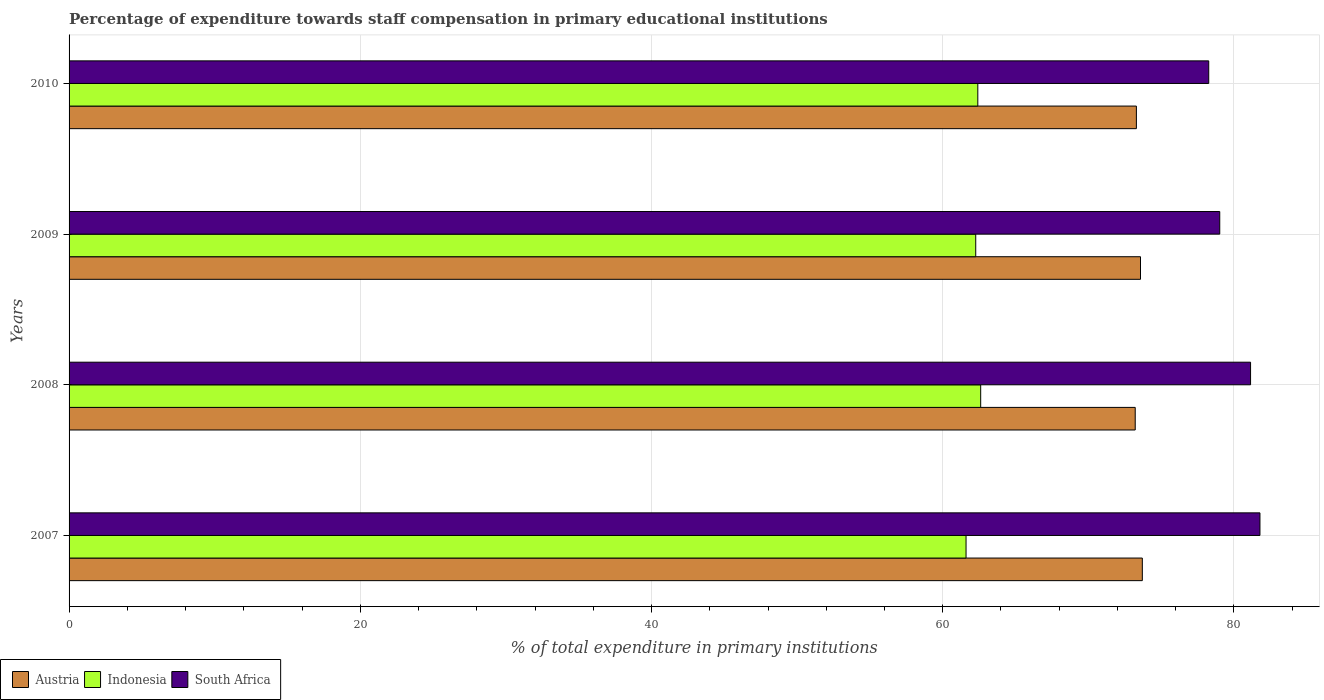How many groups of bars are there?
Ensure brevity in your answer.  4. Are the number of bars per tick equal to the number of legend labels?
Offer a very short reply. Yes. Are the number of bars on each tick of the Y-axis equal?
Give a very brief answer. Yes. In how many cases, is the number of bars for a given year not equal to the number of legend labels?
Your answer should be compact. 0. What is the percentage of expenditure towards staff compensation in South Africa in 2010?
Your response must be concise. 78.27. Across all years, what is the maximum percentage of expenditure towards staff compensation in Austria?
Offer a terse response. 73.71. Across all years, what is the minimum percentage of expenditure towards staff compensation in Indonesia?
Make the answer very short. 61.6. In which year was the percentage of expenditure towards staff compensation in Indonesia maximum?
Your response must be concise. 2008. What is the total percentage of expenditure towards staff compensation in South Africa in the graph?
Provide a succinct answer. 320.22. What is the difference between the percentage of expenditure towards staff compensation in South Africa in 2009 and that in 2010?
Provide a succinct answer. 0.76. What is the difference between the percentage of expenditure towards staff compensation in Austria in 2009 and the percentage of expenditure towards staff compensation in South Africa in 2008?
Keep it short and to the point. -7.56. What is the average percentage of expenditure towards staff compensation in Austria per year?
Keep it short and to the point. 73.45. In the year 2009, what is the difference between the percentage of expenditure towards staff compensation in Indonesia and percentage of expenditure towards staff compensation in South Africa?
Your answer should be very brief. -16.76. In how many years, is the percentage of expenditure towards staff compensation in Indonesia greater than 4 %?
Keep it short and to the point. 4. What is the ratio of the percentage of expenditure towards staff compensation in Indonesia in 2008 to that in 2009?
Your response must be concise. 1.01. Is the percentage of expenditure towards staff compensation in Austria in 2009 less than that in 2010?
Offer a very short reply. No. What is the difference between the highest and the second highest percentage of expenditure towards staff compensation in South Africa?
Keep it short and to the point. 0.64. What is the difference between the highest and the lowest percentage of expenditure towards staff compensation in Austria?
Ensure brevity in your answer.  0.49. What does the 2nd bar from the top in 2009 represents?
Your answer should be very brief. Indonesia. How many bars are there?
Offer a very short reply. 12. How many years are there in the graph?
Offer a very short reply. 4. Are the values on the major ticks of X-axis written in scientific E-notation?
Offer a very short reply. No. Where does the legend appear in the graph?
Give a very brief answer. Bottom left. How many legend labels are there?
Offer a very short reply. 3. How are the legend labels stacked?
Give a very brief answer. Horizontal. What is the title of the graph?
Your answer should be very brief. Percentage of expenditure towards staff compensation in primary educational institutions. What is the label or title of the X-axis?
Ensure brevity in your answer.  % of total expenditure in primary institutions. What is the label or title of the Y-axis?
Your answer should be very brief. Years. What is the % of total expenditure in primary institutions in Austria in 2007?
Provide a short and direct response. 73.71. What is the % of total expenditure in primary institutions in Indonesia in 2007?
Give a very brief answer. 61.6. What is the % of total expenditure in primary institutions in South Africa in 2007?
Keep it short and to the point. 81.79. What is the % of total expenditure in primary institutions in Austria in 2008?
Make the answer very short. 73.22. What is the % of total expenditure in primary institutions in Indonesia in 2008?
Ensure brevity in your answer.  62.61. What is the % of total expenditure in primary institutions of South Africa in 2008?
Provide a succinct answer. 81.14. What is the % of total expenditure in primary institutions in Austria in 2009?
Your answer should be very brief. 73.58. What is the % of total expenditure in primary institutions in Indonesia in 2009?
Ensure brevity in your answer.  62.27. What is the % of total expenditure in primary institutions of South Africa in 2009?
Your answer should be very brief. 79.03. What is the % of total expenditure in primary institutions of Austria in 2010?
Ensure brevity in your answer.  73.3. What is the % of total expenditure in primary institutions of Indonesia in 2010?
Offer a terse response. 62.41. What is the % of total expenditure in primary institutions of South Africa in 2010?
Your answer should be very brief. 78.27. Across all years, what is the maximum % of total expenditure in primary institutions of Austria?
Provide a succinct answer. 73.71. Across all years, what is the maximum % of total expenditure in primary institutions in Indonesia?
Provide a short and direct response. 62.61. Across all years, what is the maximum % of total expenditure in primary institutions in South Africa?
Provide a succinct answer. 81.79. Across all years, what is the minimum % of total expenditure in primary institutions in Austria?
Your answer should be very brief. 73.22. Across all years, what is the minimum % of total expenditure in primary institutions in Indonesia?
Offer a terse response. 61.6. Across all years, what is the minimum % of total expenditure in primary institutions of South Africa?
Offer a very short reply. 78.27. What is the total % of total expenditure in primary institutions in Austria in the graph?
Offer a terse response. 293.81. What is the total % of total expenditure in primary institutions of Indonesia in the graph?
Provide a short and direct response. 248.88. What is the total % of total expenditure in primary institutions of South Africa in the graph?
Ensure brevity in your answer.  320.22. What is the difference between the % of total expenditure in primary institutions in Austria in 2007 and that in 2008?
Give a very brief answer. 0.49. What is the difference between the % of total expenditure in primary institutions in Indonesia in 2007 and that in 2008?
Give a very brief answer. -1.01. What is the difference between the % of total expenditure in primary institutions in South Africa in 2007 and that in 2008?
Ensure brevity in your answer.  0.64. What is the difference between the % of total expenditure in primary institutions in Austria in 2007 and that in 2009?
Provide a succinct answer. 0.13. What is the difference between the % of total expenditure in primary institutions of Indonesia in 2007 and that in 2009?
Make the answer very short. -0.66. What is the difference between the % of total expenditure in primary institutions of South Africa in 2007 and that in 2009?
Ensure brevity in your answer.  2.76. What is the difference between the % of total expenditure in primary institutions of Austria in 2007 and that in 2010?
Provide a short and direct response. 0.41. What is the difference between the % of total expenditure in primary institutions of Indonesia in 2007 and that in 2010?
Offer a very short reply. -0.81. What is the difference between the % of total expenditure in primary institutions of South Africa in 2007 and that in 2010?
Provide a short and direct response. 3.52. What is the difference between the % of total expenditure in primary institutions of Austria in 2008 and that in 2009?
Your response must be concise. -0.36. What is the difference between the % of total expenditure in primary institutions of Indonesia in 2008 and that in 2009?
Offer a very short reply. 0.34. What is the difference between the % of total expenditure in primary institutions of South Africa in 2008 and that in 2009?
Provide a short and direct response. 2.12. What is the difference between the % of total expenditure in primary institutions in Austria in 2008 and that in 2010?
Keep it short and to the point. -0.08. What is the difference between the % of total expenditure in primary institutions in Indonesia in 2008 and that in 2010?
Your answer should be very brief. 0.2. What is the difference between the % of total expenditure in primary institutions in South Africa in 2008 and that in 2010?
Your answer should be compact. 2.87. What is the difference between the % of total expenditure in primary institutions in Austria in 2009 and that in 2010?
Your answer should be very brief. 0.28. What is the difference between the % of total expenditure in primary institutions of Indonesia in 2009 and that in 2010?
Give a very brief answer. -0.14. What is the difference between the % of total expenditure in primary institutions in South Africa in 2009 and that in 2010?
Offer a terse response. 0.76. What is the difference between the % of total expenditure in primary institutions of Austria in 2007 and the % of total expenditure in primary institutions of Indonesia in 2008?
Make the answer very short. 11.1. What is the difference between the % of total expenditure in primary institutions of Austria in 2007 and the % of total expenditure in primary institutions of South Africa in 2008?
Ensure brevity in your answer.  -7.43. What is the difference between the % of total expenditure in primary institutions of Indonesia in 2007 and the % of total expenditure in primary institutions of South Africa in 2008?
Provide a succinct answer. -19.54. What is the difference between the % of total expenditure in primary institutions in Austria in 2007 and the % of total expenditure in primary institutions in Indonesia in 2009?
Make the answer very short. 11.44. What is the difference between the % of total expenditure in primary institutions of Austria in 2007 and the % of total expenditure in primary institutions of South Africa in 2009?
Your answer should be very brief. -5.32. What is the difference between the % of total expenditure in primary institutions in Indonesia in 2007 and the % of total expenditure in primary institutions in South Africa in 2009?
Offer a very short reply. -17.42. What is the difference between the % of total expenditure in primary institutions in Austria in 2007 and the % of total expenditure in primary institutions in Indonesia in 2010?
Make the answer very short. 11.3. What is the difference between the % of total expenditure in primary institutions of Austria in 2007 and the % of total expenditure in primary institutions of South Africa in 2010?
Offer a very short reply. -4.56. What is the difference between the % of total expenditure in primary institutions in Indonesia in 2007 and the % of total expenditure in primary institutions in South Africa in 2010?
Make the answer very short. -16.67. What is the difference between the % of total expenditure in primary institutions of Austria in 2008 and the % of total expenditure in primary institutions of Indonesia in 2009?
Your answer should be very brief. 10.95. What is the difference between the % of total expenditure in primary institutions in Austria in 2008 and the % of total expenditure in primary institutions in South Africa in 2009?
Ensure brevity in your answer.  -5.81. What is the difference between the % of total expenditure in primary institutions in Indonesia in 2008 and the % of total expenditure in primary institutions in South Africa in 2009?
Your answer should be very brief. -16.42. What is the difference between the % of total expenditure in primary institutions in Austria in 2008 and the % of total expenditure in primary institutions in Indonesia in 2010?
Give a very brief answer. 10.81. What is the difference between the % of total expenditure in primary institutions in Austria in 2008 and the % of total expenditure in primary institutions in South Africa in 2010?
Provide a succinct answer. -5.05. What is the difference between the % of total expenditure in primary institutions in Indonesia in 2008 and the % of total expenditure in primary institutions in South Africa in 2010?
Ensure brevity in your answer.  -15.66. What is the difference between the % of total expenditure in primary institutions of Austria in 2009 and the % of total expenditure in primary institutions of Indonesia in 2010?
Provide a succinct answer. 11.17. What is the difference between the % of total expenditure in primary institutions in Austria in 2009 and the % of total expenditure in primary institutions in South Africa in 2010?
Your answer should be very brief. -4.69. What is the difference between the % of total expenditure in primary institutions in Indonesia in 2009 and the % of total expenditure in primary institutions in South Africa in 2010?
Your answer should be very brief. -16. What is the average % of total expenditure in primary institutions in Austria per year?
Give a very brief answer. 73.45. What is the average % of total expenditure in primary institutions in Indonesia per year?
Offer a terse response. 62.22. What is the average % of total expenditure in primary institutions of South Africa per year?
Offer a terse response. 80.06. In the year 2007, what is the difference between the % of total expenditure in primary institutions in Austria and % of total expenditure in primary institutions in Indonesia?
Give a very brief answer. 12.11. In the year 2007, what is the difference between the % of total expenditure in primary institutions of Austria and % of total expenditure in primary institutions of South Africa?
Your answer should be very brief. -8.08. In the year 2007, what is the difference between the % of total expenditure in primary institutions in Indonesia and % of total expenditure in primary institutions in South Africa?
Offer a terse response. -20.18. In the year 2008, what is the difference between the % of total expenditure in primary institutions in Austria and % of total expenditure in primary institutions in Indonesia?
Provide a succinct answer. 10.61. In the year 2008, what is the difference between the % of total expenditure in primary institutions of Austria and % of total expenditure in primary institutions of South Africa?
Keep it short and to the point. -7.92. In the year 2008, what is the difference between the % of total expenditure in primary institutions of Indonesia and % of total expenditure in primary institutions of South Africa?
Your answer should be compact. -18.53. In the year 2009, what is the difference between the % of total expenditure in primary institutions of Austria and % of total expenditure in primary institutions of Indonesia?
Provide a succinct answer. 11.32. In the year 2009, what is the difference between the % of total expenditure in primary institutions in Austria and % of total expenditure in primary institutions in South Africa?
Provide a short and direct response. -5.44. In the year 2009, what is the difference between the % of total expenditure in primary institutions of Indonesia and % of total expenditure in primary institutions of South Africa?
Provide a succinct answer. -16.76. In the year 2010, what is the difference between the % of total expenditure in primary institutions in Austria and % of total expenditure in primary institutions in Indonesia?
Your answer should be very brief. 10.89. In the year 2010, what is the difference between the % of total expenditure in primary institutions of Austria and % of total expenditure in primary institutions of South Africa?
Offer a terse response. -4.97. In the year 2010, what is the difference between the % of total expenditure in primary institutions of Indonesia and % of total expenditure in primary institutions of South Africa?
Your response must be concise. -15.86. What is the ratio of the % of total expenditure in primary institutions of Austria in 2007 to that in 2008?
Offer a very short reply. 1.01. What is the ratio of the % of total expenditure in primary institutions in Indonesia in 2007 to that in 2008?
Your response must be concise. 0.98. What is the ratio of the % of total expenditure in primary institutions in South Africa in 2007 to that in 2008?
Give a very brief answer. 1.01. What is the ratio of the % of total expenditure in primary institutions of Austria in 2007 to that in 2009?
Offer a very short reply. 1. What is the ratio of the % of total expenditure in primary institutions in Indonesia in 2007 to that in 2009?
Your answer should be very brief. 0.99. What is the ratio of the % of total expenditure in primary institutions in South Africa in 2007 to that in 2009?
Make the answer very short. 1.03. What is the ratio of the % of total expenditure in primary institutions of Austria in 2007 to that in 2010?
Provide a short and direct response. 1.01. What is the ratio of the % of total expenditure in primary institutions of Indonesia in 2007 to that in 2010?
Ensure brevity in your answer.  0.99. What is the ratio of the % of total expenditure in primary institutions of South Africa in 2007 to that in 2010?
Give a very brief answer. 1.04. What is the ratio of the % of total expenditure in primary institutions of Indonesia in 2008 to that in 2009?
Keep it short and to the point. 1.01. What is the ratio of the % of total expenditure in primary institutions in South Africa in 2008 to that in 2009?
Give a very brief answer. 1.03. What is the ratio of the % of total expenditure in primary institutions of South Africa in 2008 to that in 2010?
Make the answer very short. 1.04. What is the ratio of the % of total expenditure in primary institutions of Indonesia in 2009 to that in 2010?
Provide a succinct answer. 1. What is the ratio of the % of total expenditure in primary institutions of South Africa in 2009 to that in 2010?
Your answer should be compact. 1.01. What is the difference between the highest and the second highest % of total expenditure in primary institutions of Austria?
Ensure brevity in your answer.  0.13. What is the difference between the highest and the second highest % of total expenditure in primary institutions in Indonesia?
Offer a very short reply. 0.2. What is the difference between the highest and the second highest % of total expenditure in primary institutions of South Africa?
Provide a succinct answer. 0.64. What is the difference between the highest and the lowest % of total expenditure in primary institutions in Austria?
Keep it short and to the point. 0.49. What is the difference between the highest and the lowest % of total expenditure in primary institutions in Indonesia?
Provide a short and direct response. 1.01. What is the difference between the highest and the lowest % of total expenditure in primary institutions of South Africa?
Your response must be concise. 3.52. 